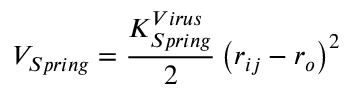Convert formula to latex. <formula><loc_0><loc_0><loc_500><loc_500>V _ { S p r i n g } = \frac { K _ { S p r i n g } ^ { V i r u s } } { 2 } \left ( r _ { i j } - r _ { o } \right ) ^ { 2 }</formula> 